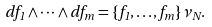Convert formula to latex. <formula><loc_0><loc_0><loc_500><loc_500>d f _ { 1 } \wedge \dots \wedge d f _ { m } = \{ f _ { 1 } , \dots , f _ { m } \} \nu _ { N } .</formula> 